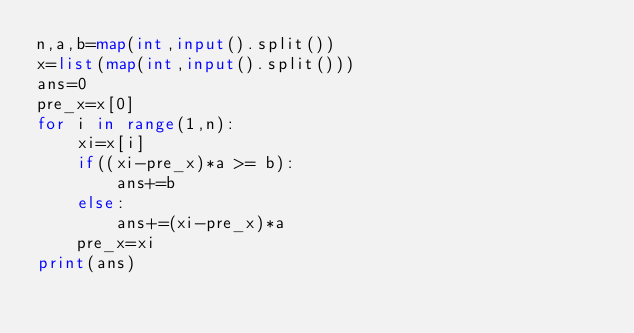Convert code to text. <code><loc_0><loc_0><loc_500><loc_500><_Python_>n,a,b=map(int,input().split())
x=list(map(int,input().split()))
ans=0
pre_x=x[0]
for i in range(1,n):
    xi=x[i]
    if((xi-pre_x)*a >= b):
        ans+=b
    else:
        ans+=(xi-pre_x)*a
    pre_x=xi
print(ans)</code> 